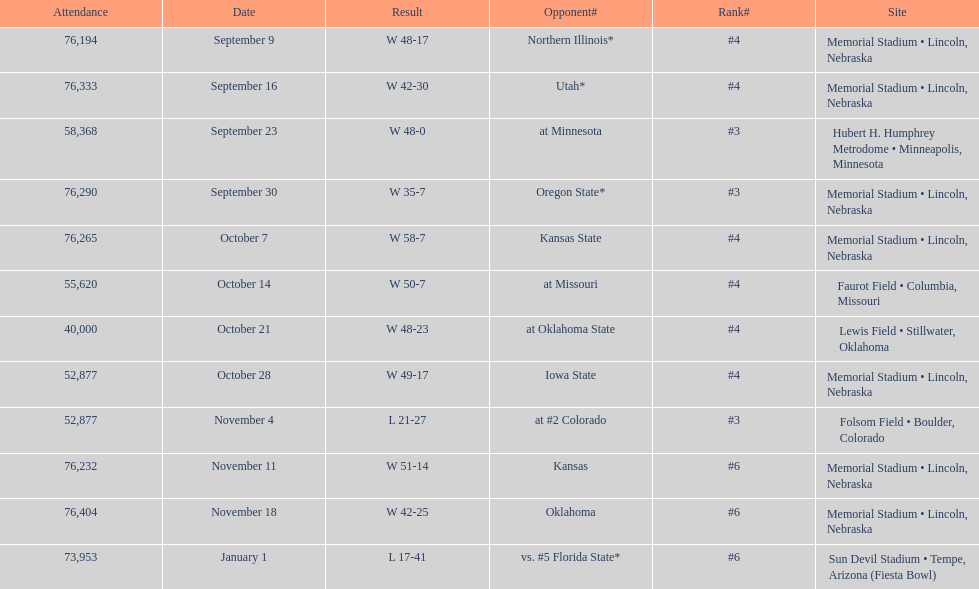How frequently does "w" occur as the result on average? 10. 